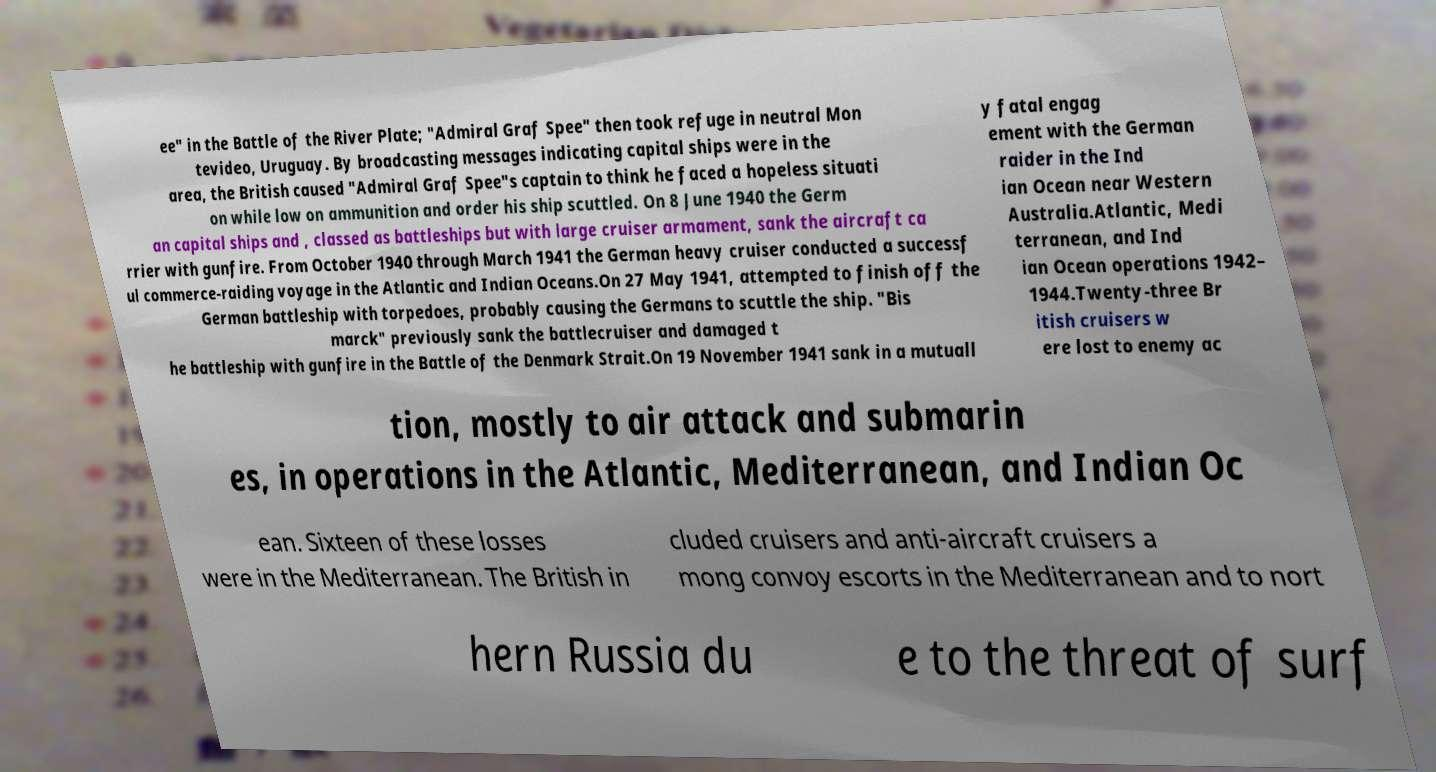For documentation purposes, I need the text within this image transcribed. Could you provide that? ee" in the Battle of the River Plate; "Admiral Graf Spee" then took refuge in neutral Mon tevideo, Uruguay. By broadcasting messages indicating capital ships were in the area, the British caused "Admiral Graf Spee"s captain to think he faced a hopeless situati on while low on ammunition and order his ship scuttled. On 8 June 1940 the Germ an capital ships and , classed as battleships but with large cruiser armament, sank the aircraft ca rrier with gunfire. From October 1940 through March 1941 the German heavy cruiser conducted a successf ul commerce-raiding voyage in the Atlantic and Indian Oceans.On 27 May 1941, attempted to finish off the German battleship with torpedoes, probably causing the Germans to scuttle the ship. "Bis marck" previously sank the battlecruiser and damaged t he battleship with gunfire in the Battle of the Denmark Strait.On 19 November 1941 sank in a mutuall y fatal engag ement with the German raider in the Ind ian Ocean near Western Australia.Atlantic, Medi terranean, and Ind ian Ocean operations 1942– 1944.Twenty-three Br itish cruisers w ere lost to enemy ac tion, mostly to air attack and submarin es, in operations in the Atlantic, Mediterranean, and Indian Oc ean. Sixteen of these losses were in the Mediterranean. The British in cluded cruisers and anti-aircraft cruisers a mong convoy escorts in the Mediterranean and to nort hern Russia du e to the threat of surf 